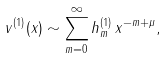<formula> <loc_0><loc_0><loc_500><loc_500>v ^ { ( 1 ) } ( x ) \sim \sum _ { m = 0 } ^ { \infty } h _ { m } ^ { ( 1 ) } \, x ^ { - m + \mu } ,</formula> 